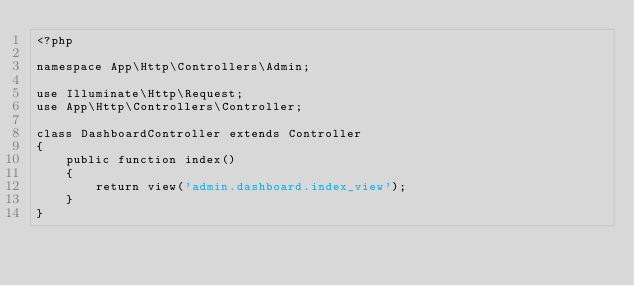Convert code to text. <code><loc_0><loc_0><loc_500><loc_500><_PHP_><?php

namespace App\Http\Controllers\Admin;

use Illuminate\Http\Request;
use App\Http\Controllers\Controller;

class DashboardController extends Controller
{
    public function index()
    {
    	return view('admin.dashboard.index_view');
    }
}
</code> 